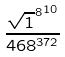Convert formula to latex. <formula><loc_0><loc_0><loc_500><loc_500>\frac { { \sqrt { 1 } ^ { 8 } } ^ { 1 0 } } { 4 6 8 ^ { 3 7 2 } }</formula> 